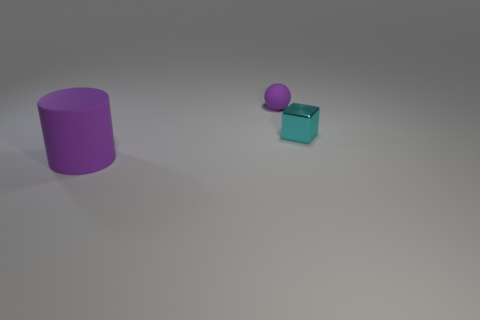Add 2 cyan metallic things. How many objects exist? 5 Subtract all cylinders. How many objects are left? 2 Add 1 large purple objects. How many large purple objects are left? 2 Add 3 large cyan metal objects. How many large cyan metal objects exist? 3 Subtract 1 purple balls. How many objects are left? 2 Subtract all big purple rubber things. Subtract all big rubber objects. How many objects are left? 1 